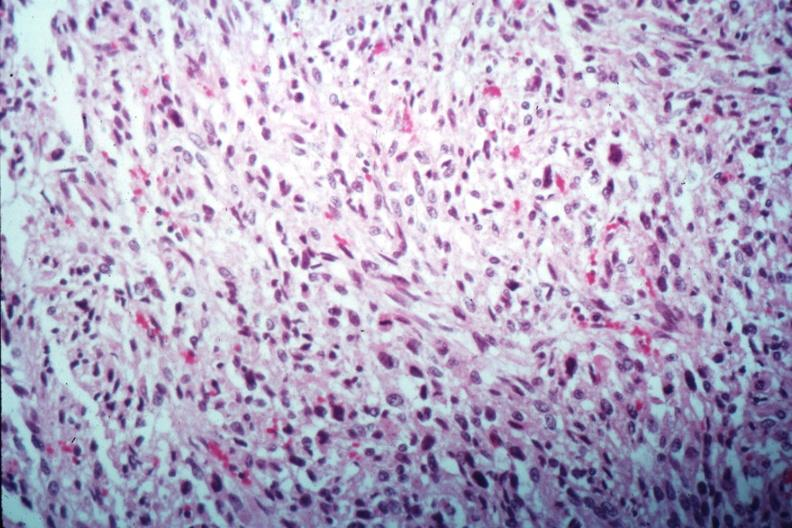s uterus present?
Answer the question using a single word or phrase. Yes 